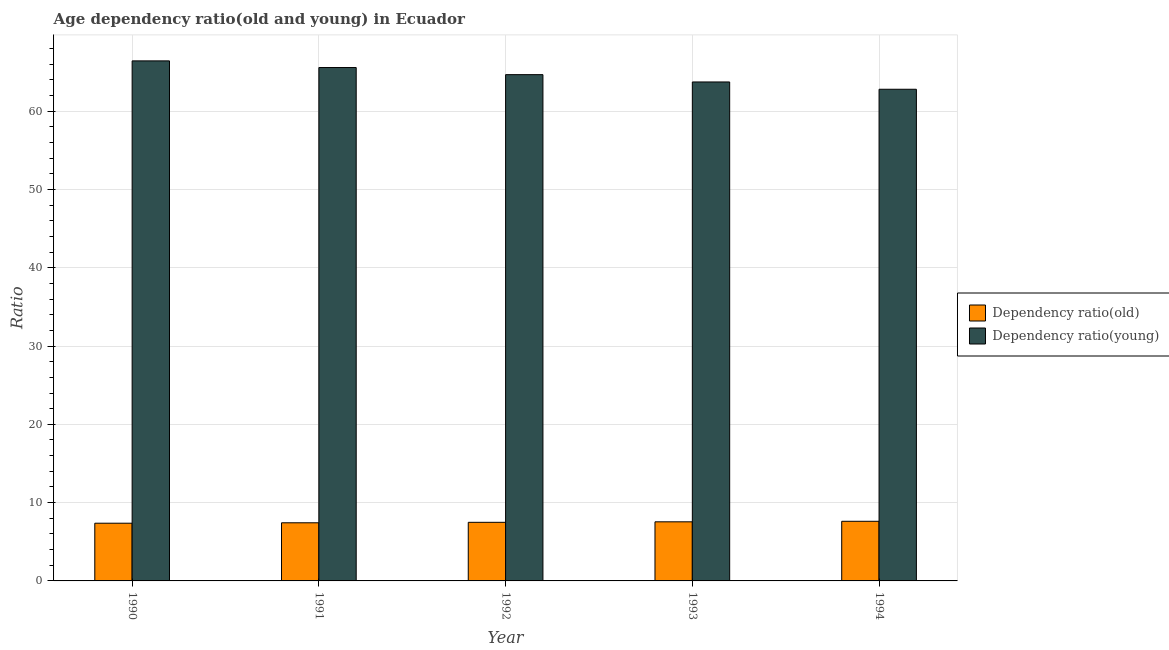How many different coloured bars are there?
Your answer should be very brief. 2. Are the number of bars per tick equal to the number of legend labels?
Your answer should be very brief. Yes. What is the label of the 3rd group of bars from the left?
Make the answer very short. 1992. In how many cases, is the number of bars for a given year not equal to the number of legend labels?
Your response must be concise. 0. What is the age dependency ratio(old) in 1993?
Ensure brevity in your answer.  7.55. Across all years, what is the maximum age dependency ratio(old)?
Make the answer very short. 7.62. Across all years, what is the minimum age dependency ratio(old)?
Provide a succinct answer. 7.37. What is the total age dependency ratio(old) in the graph?
Offer a very short reply. 37.44. What is the difference between the age dependency ratio(young) in 1991 and that in 1993?
Provide a succinct answer. 1.84. What is the difference between the age dependency ratio(young) in 1990 and the age dependency ratio(old) in 1991?
Your answer should be compact. 0.85. What is the average age dependency ratio(young) per year?
Your answer should be very brief. 64.64. In the year 1994, what is the difference between the age dependency ratio(old) and age dependency ratio(young)?
Offer a terse response. 0. In how many years, is the age dependency ratio(old) greater than 22?
Your answer should be compact. 0. What is the ratio of the age dependency ratio(young) in 1991 to that in 1994?
Offer a terse response. 1.04. Is the difference between the age dependency ratio(old) in 1990 and 1992 greater than the difference between the age dependency ratio(young) in 1990 and 1992?
Your answer should be compact. No. What is the difference between the highest and the second highest age dependency ratio(old)?
Provide a short and direct response. 0.07. What is the difference between the highest and the lowest age dependency ratio(young)?
Provide a short and direct response. 3.62. In how many years, is the age dependency ratio(old) greater than the average age dependency ratio(old) taken over all years?
Provide a succinct answer. 2. What does the 2nd bar from the left in 1992 represents?
Ensure brevity in your answer.  Dependency ratio(young). What does the 1st bar from the right in 1991 represents?
Keep it short and to the point. Dependency ratio(young). Are all the bars in the graph horizontal?
Your response must be concise. No. How many years are there in the graph?
Provide a succinct answer. 5. What is the difference between two consecutive major ticks on the Y-axis?
Provide a short and direct response. 10. Are the values on the major ticks of Y-axis written in scientific E-notation?
Give a very brief answer. No. Does the graph contain any zero values?
Give a very brief answer. No. Where does the legend appear in the graph?
Offer a very short reply. Center right. How many legend labels are there?
Provide a short and direct response. 2. What is the title of the graph?
Your response must be concise. Age dependency ratio(old and young) in Ecuador. Does "Electricity" appear as one of the legend labels in the graph?
Give a very brief answer. No. What is the label or title of the Y-axis?
Offer a terse response. Ratio. What is the Ratio of Dependency ratio(old) in 1990?
Make the answer very short. 7.37. What is the Ratio in Dependency ratio(young) in 1990?
Make the answer very short. 66.42. What is the Ratio of Dependency ratio(old) in 1991?
Provide a succinct answer. 7.43. What is the Ratio of Dependency ratio(young) in 1991?
Make the answer very short. 65.57. What is the Ratio of Dependency ratio(old) in 1992?
Provide a succinct answer. 7.48. What is the Ratio of Dependency ratio(young) in 1992?
Provide a succinct answer. 64.66. What is the Ratio of Dependency ratio(old) in 1993?
Provide a short and direct response. 7.55. What is the Ratio of Dependency ratio(young) in 1993?
Provide a short and direct response. 63.73. What is the Ratio in Dependency ratio(old) in 1994?
Provide a succinct answer. 7.62. What is the Ratio of Dependency ratio(young) in 1994?
Keep it short and to the point. 62.8. Across all years, what is the maximum Ratio of Dependency ratio(old)?
Ensure brevity in your answer.  7.62. Across all years, what is the maximum Ratio of Dependency ratio(young)?
Your response must be concise. 66.42. Across all years, what is the minimum Ratio in Dependency ratio(old)?
Keep it short and to the point. 7.37. Across all years, what is the minimum Ratio in Dependency ratio(young)?
Your answer should be very brief. 62.8. What is the total Ratio of Dependency ratio(old) in the graph?
Your response must be concise. 37.44. What is the total Ratio in Dependency ratio(young) in the graph?
Provide a short and direct response. 323.18. What is the difference between the Ratio in Dependency ratio(old) in 1990 and that in 1991?
Your answer should be very brief. -0.06. What is the difference between the Ratio in Dependency ratio(young) in 1990 and that in 1991?
Give a very brief answer. 0.85. What is the difference between the Ratio of Dependency ratio(old) in 1990 and that in 1992?
Your answer should be compact. -0.11. What is the difference between the Ratio of Dependency ratio(young) in 1990 and that in 1992?
Make the answer very short. 1.76. What is the difference between the Ratio of Dependency ratio(old) in 1990 and that in 1993?
Give a very brief answer. -0.18. What is the difference between the Ratio in Dependency ratio(young) in 1990 and that in 1993?
Your response must be concise. 2.69. What is the difference between the Ratio of Dependency ratio(old) in 1990 and that in 1994?
Make the answer very short. -0.25. What is the difference between the Ratio in Dependency ratio(young) in 1990 and that in 1994?
Provide a short and direct response. 3.62. What is the difference between the Ratio of Dependency ratio(old) in 1991 and that in 1992?
Offer a very short reply. -0.06. What is the difference between the Ratio of Dependency ratio(young) in 1991 and that in 1992?
Provide a short and direct response. 0.91. What is the difference between the Ratio in Dependency ratio(old) in 1991 and that in 1993?
Ensure brevity in your answer.  -0.12. What is the difference between the Ratio of Dependency ratio(young) in 1991 and that in 1993?
Make the answer very short. 1.84. What is the difference between the Ratio in Dependency ratio(old) in 1991 and that in 1994?
Your answer should be compact. -0.19. What is the difference between the Ratio of Dependency ratio(young) in 1991 and that in 1994?
Provide a short and direct response. 2.77. What is the difference between the Ratio in Dependency ratio(old) in 1992 and that in 1993?
Make the answer very short. -0.06. What is the difference between the Ratio of Dependency ratio(young) in 1992 and that in 1993?
Give a very brief answer. 0.93. What is the difference between the Ratio of Dependency ratio(old) in 1992 and that in 1994?
Your response must be concise. -0.13. What is the difference between the Ratio in Dependency ratio(young) in 1992 and that in 1994?
Your answer should be compact. 1.87. What is the difference between the Ratio of Dependency ratio(old) in 1993 and that in 1994?
Offer a terse response. -0.07. What is the difference between the Ratio in Dependency ratio(young) in 1993 and that in 1994?
Make the answer very short. 0.93. What is the difference between the Ratio in Dependency ratio(old) in 1990 and the Ratio in Dependency ratio(young) in 1991?
Your answer should be compact. -58.2. What is the difference between the Ratio in Dependency ratio(old) in 1990 and the Ratio in Dependency ratio(young) in 1992?
Your answer should be very brief. -57.29. What is the difference between the Ratio of Dependency ratio(old) in 1990 and the Ratio of Dependency ratio(young) in 1993?
Your answer should be very brief. -56.36. What is the difference between the Ratio of Dependency ratio(old) in 1990 and the Ratio of Dependency ratio(young) in 1994?
Offer a very short reply. -55.43. What is the difference between the Ratio of Dependency ratio(old) in 1991 and the Ratio of Dependency ratio(young) in 1992?
Ensure brevity in your answer.  -57.24. What is the difference between the Ratio in Dependency ratio(old) in 1991 and the Ratio in Dependency ratio(young) in 1993?
Keep it short and to the point. -56.3. What is the difference between the Ratio of Dependency ratio(old) in 1991 and the Ratio of Dependency ratio(young) in 1994?
Your answer should be compact. -55.37. What is the difference between the Ratio of Dependency ratio(old) in 1992 and the Ratio of Dependency ratio(young) in 1993?
Your answer should be very brief. -56.24. What is the difference between the Ratio of Dependency ratio(old) in 1992 and the Ratio of Dependency ratio(young) in 1994?
Keep it short and to the point. -55.31. What is the difference between the Ratio in Dependency ratio(old) in 1993 and the Ratio in Dependency ratio(young) in 1994?
Provide a short and direct response. -55.25. What is the average Ratio of Dependency ratio(old) per year?
Your answer should be very brief. 7.49. What is the average Ratio of Dependency ratio(young) per year?
Keep it short and to the point. 64.64. In the year 1990, what is the difference between the Ratio of Dependency ratio(old) and Ratio of Dependency ratio(young)?
Provide a succinct answer. -59.05. In the year 1991, what is the difference between the Ratio in Dependency ratio(old) and Ratio in Dependency ratio(young)?
Keep it short and to the point. -58.14. In the year 1992, what is the difference between the Ratio of Dependency ratio(old) and Ratio of Dependency ratio(young)?
Your response must be concise. -57.18. In the year 1993, what is the difference between the Ratio of Dependency ratio(old) and Ratio of Dependency ratio(young)?
Keep it short and to the point. -56.18. In the year 1994, what is the difference between the Ratio in Dependency ratio(old) and Ratio in Dependency ratio(young)?
Offer a very short reply. -55.18. What is the ratio of the Ratio of Dependency ratio(young) in 1990 to that in 1991?
Keep it short and to the point. 1.01. What is the ratio of the Ratio in Dependency ratio(old) in 1990 to that in 1992?
Provide a succinct answer. 0.98. What is the ratio of the Ratio in Dependency ratio(young) in 1990 to that in 1992?
Offer a terse response. 1.03. What is the ratio of the Ratio in Dependency ratio(old) in 1990 to that in 1993?
Offer a terse response. 0.98. What is the ratio of the Ratio in Dependency ratio(young) in 1990 to that in 1993?
Ensure brevity in your answer.  1.04. What is the ratio of the Ratio in Dependency ratio(young) in 1990 to that in 1994?
Provide a succinct answer. 1.06. What is the ratio of the Ratio of Dependency ratio(old) in 1991 to that in 1993?
Your response must be concise. 0.98. What is the ratio of the Ratio of Dependency ratio(young) in 1991 to that in 1993?
Your response must be concise. 1.03. What is the ratio of the Ratio of Dependency ratio(old) in 1991 to that in 1994?
Ensure brevity in your answer.  0.97. What is the ratio of the Ratio of Dependency ratio(young) in 1991 to that in 1994?
Provide a short and direct response. 1.04. What is the ratio of the Ratio of Dependency ratio(old) in 1992 to that in 1993?
Give a very brief answer. 0.99. What is the ratio of the Ratio in Dependency ratio(young) in 1992 to that in 1993?
Provide a short and direct response. 1.01. What is the ratio of the Ratio of Dependency ratio(old) in 1992 to that in 1994?
Offer a terse response. 0.98. What is the ratio of the Ratio of Dependency ratio(young) in 1992 to that in 1994?
Keep it short and to the point. 1.03. What is the ratio of the Ratio of Dependency ratio(old) in 1993 to that in 1994?
Your response must be concise. 0.99. What is the ratio of the Ratio in Dependency ratio(young) in 1993 to that in 1994?
Offer a very short reply. 1.01. What is the difference between the highest and the second highest Ratio in Dependency ratio(old)?
Provide a short and direct response. 0.07. What is the difference between the highest and the second highest Ratio in Dependency ratio(young)?
Keep it short and to the point. 0.85. What is the difference between the highest and the lowest Ratio in Dependency ratio(old)?
Offer a terse response. 0.25. What is the difference between the highest and the lowest Ratio of Dependency ratio(young)?
Ensure brevity in your answer.  3.62. 